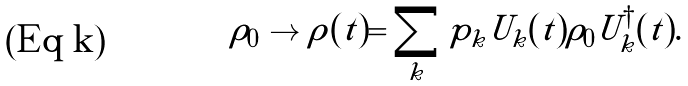Convert formula to latex. <formula><loc_0><loc_0><loc_500><loc_500>\rho _ { 0 } \to \rho ( t ) = \sum _ { k } p _ { k } U _ { k } ( t ) \rho _ { 0 } U _ { k } ^ { \dagger } ( t ) .</formula> 